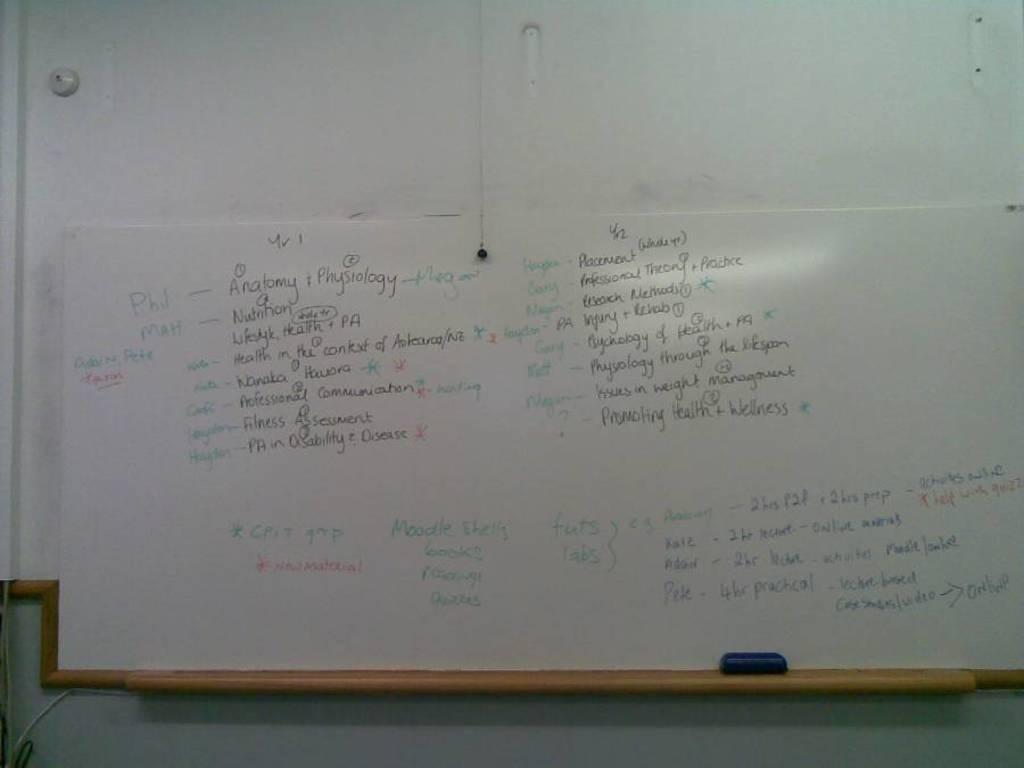What are the notes about?
Provide a short and direct response. Anatomy. 